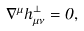<formula> <loc_0><loc_0><loc_500><loc_500>\nabla ^ { \mu } \bar { h } _ { \mu \nu } ^ { \bot } = 0 ,</formula> 